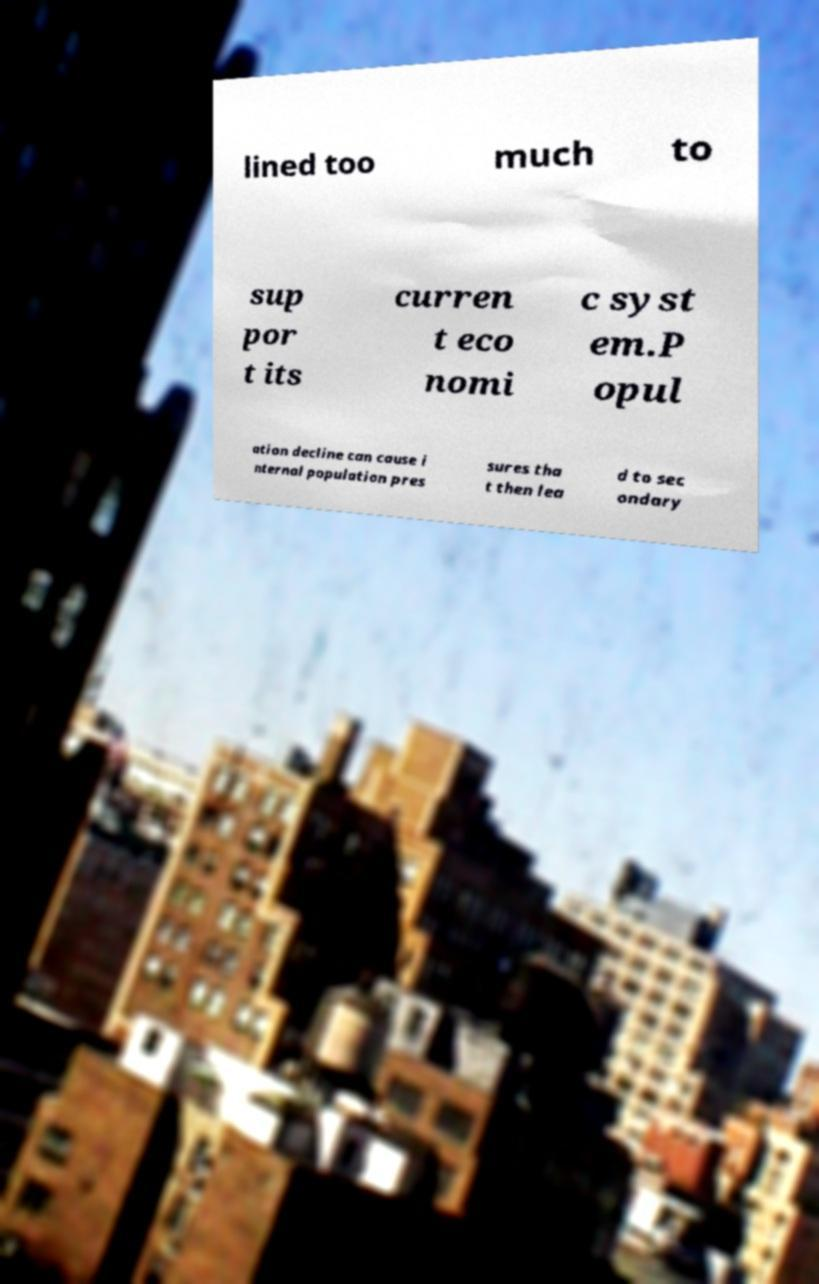There's text embedded in this image that I need extracted. Can you transcribe it verbatim? lined too much to sup por t its curren t eco nomi c syst em.P opul ation decline can cause i nternal population pres sures tha t then lea d to sec ondary 